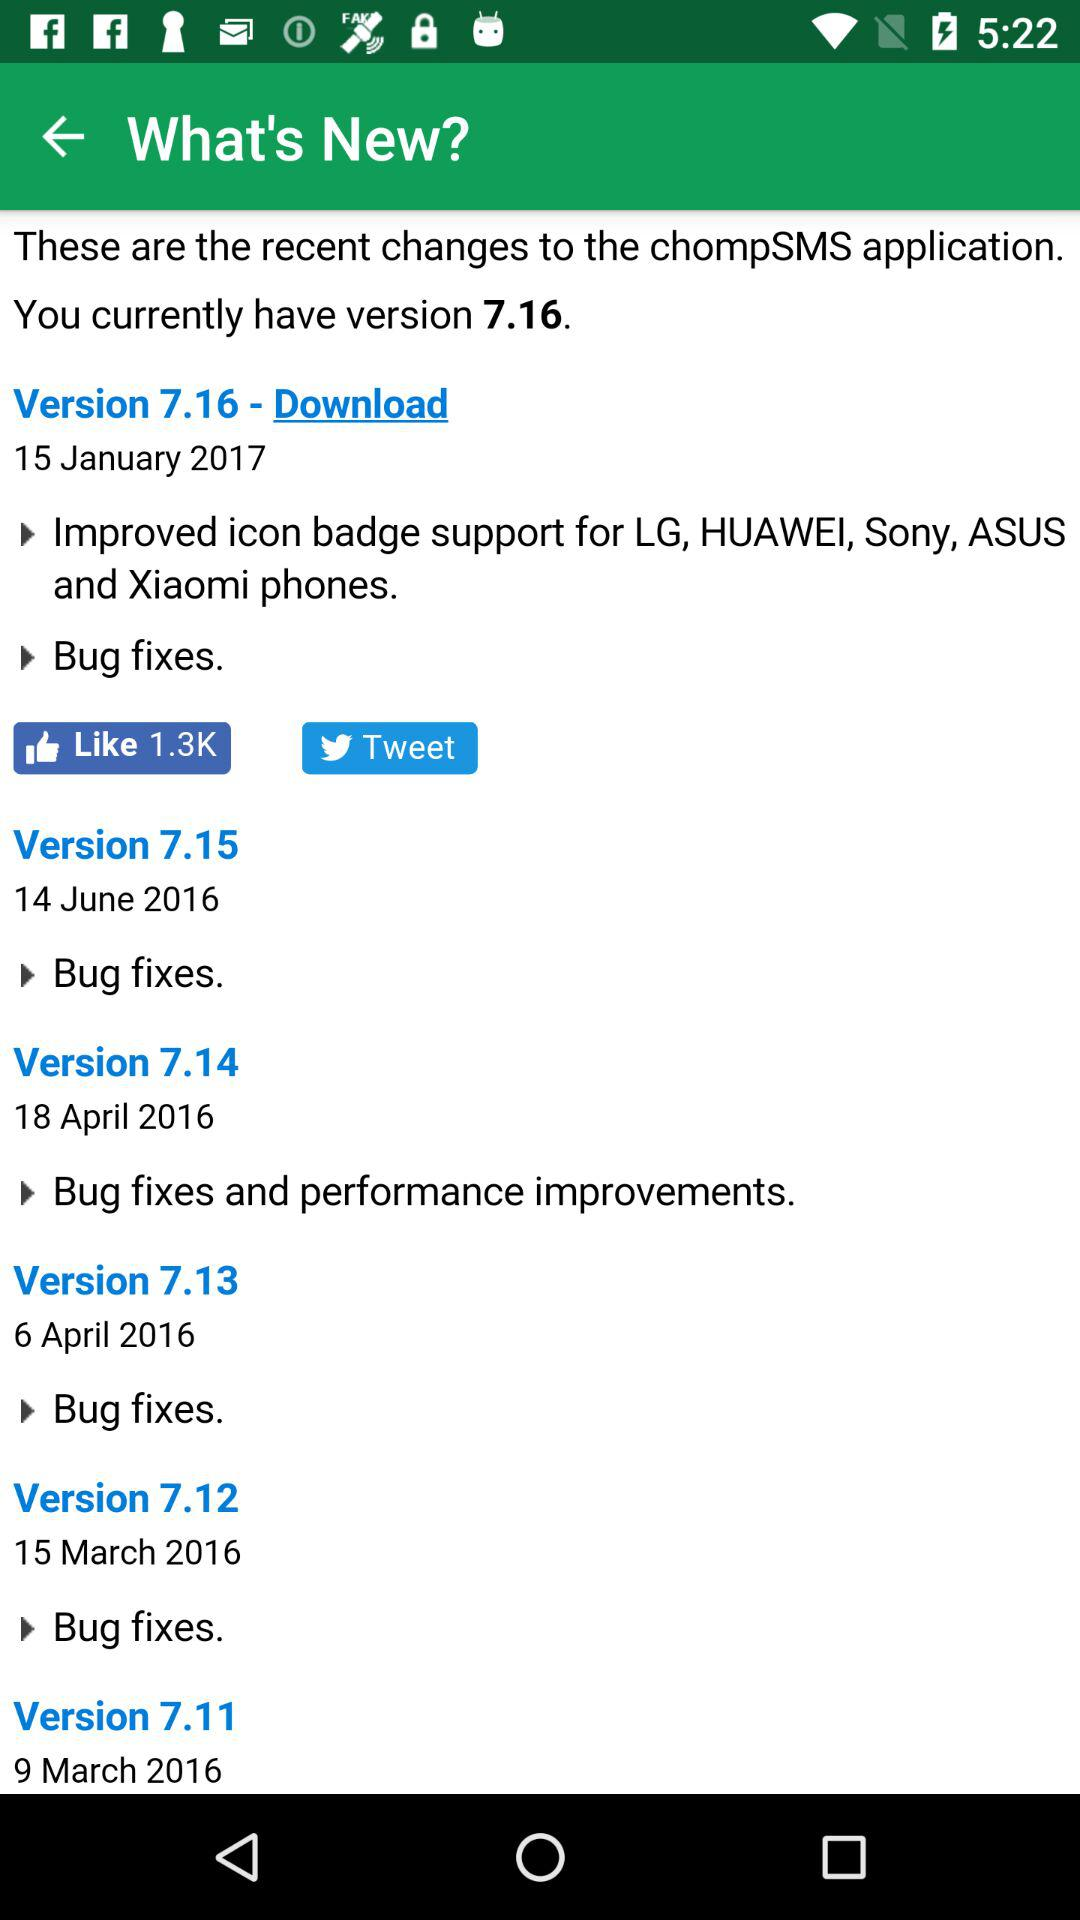What is the date of the version 7.12? The date is March 15, 2016. 